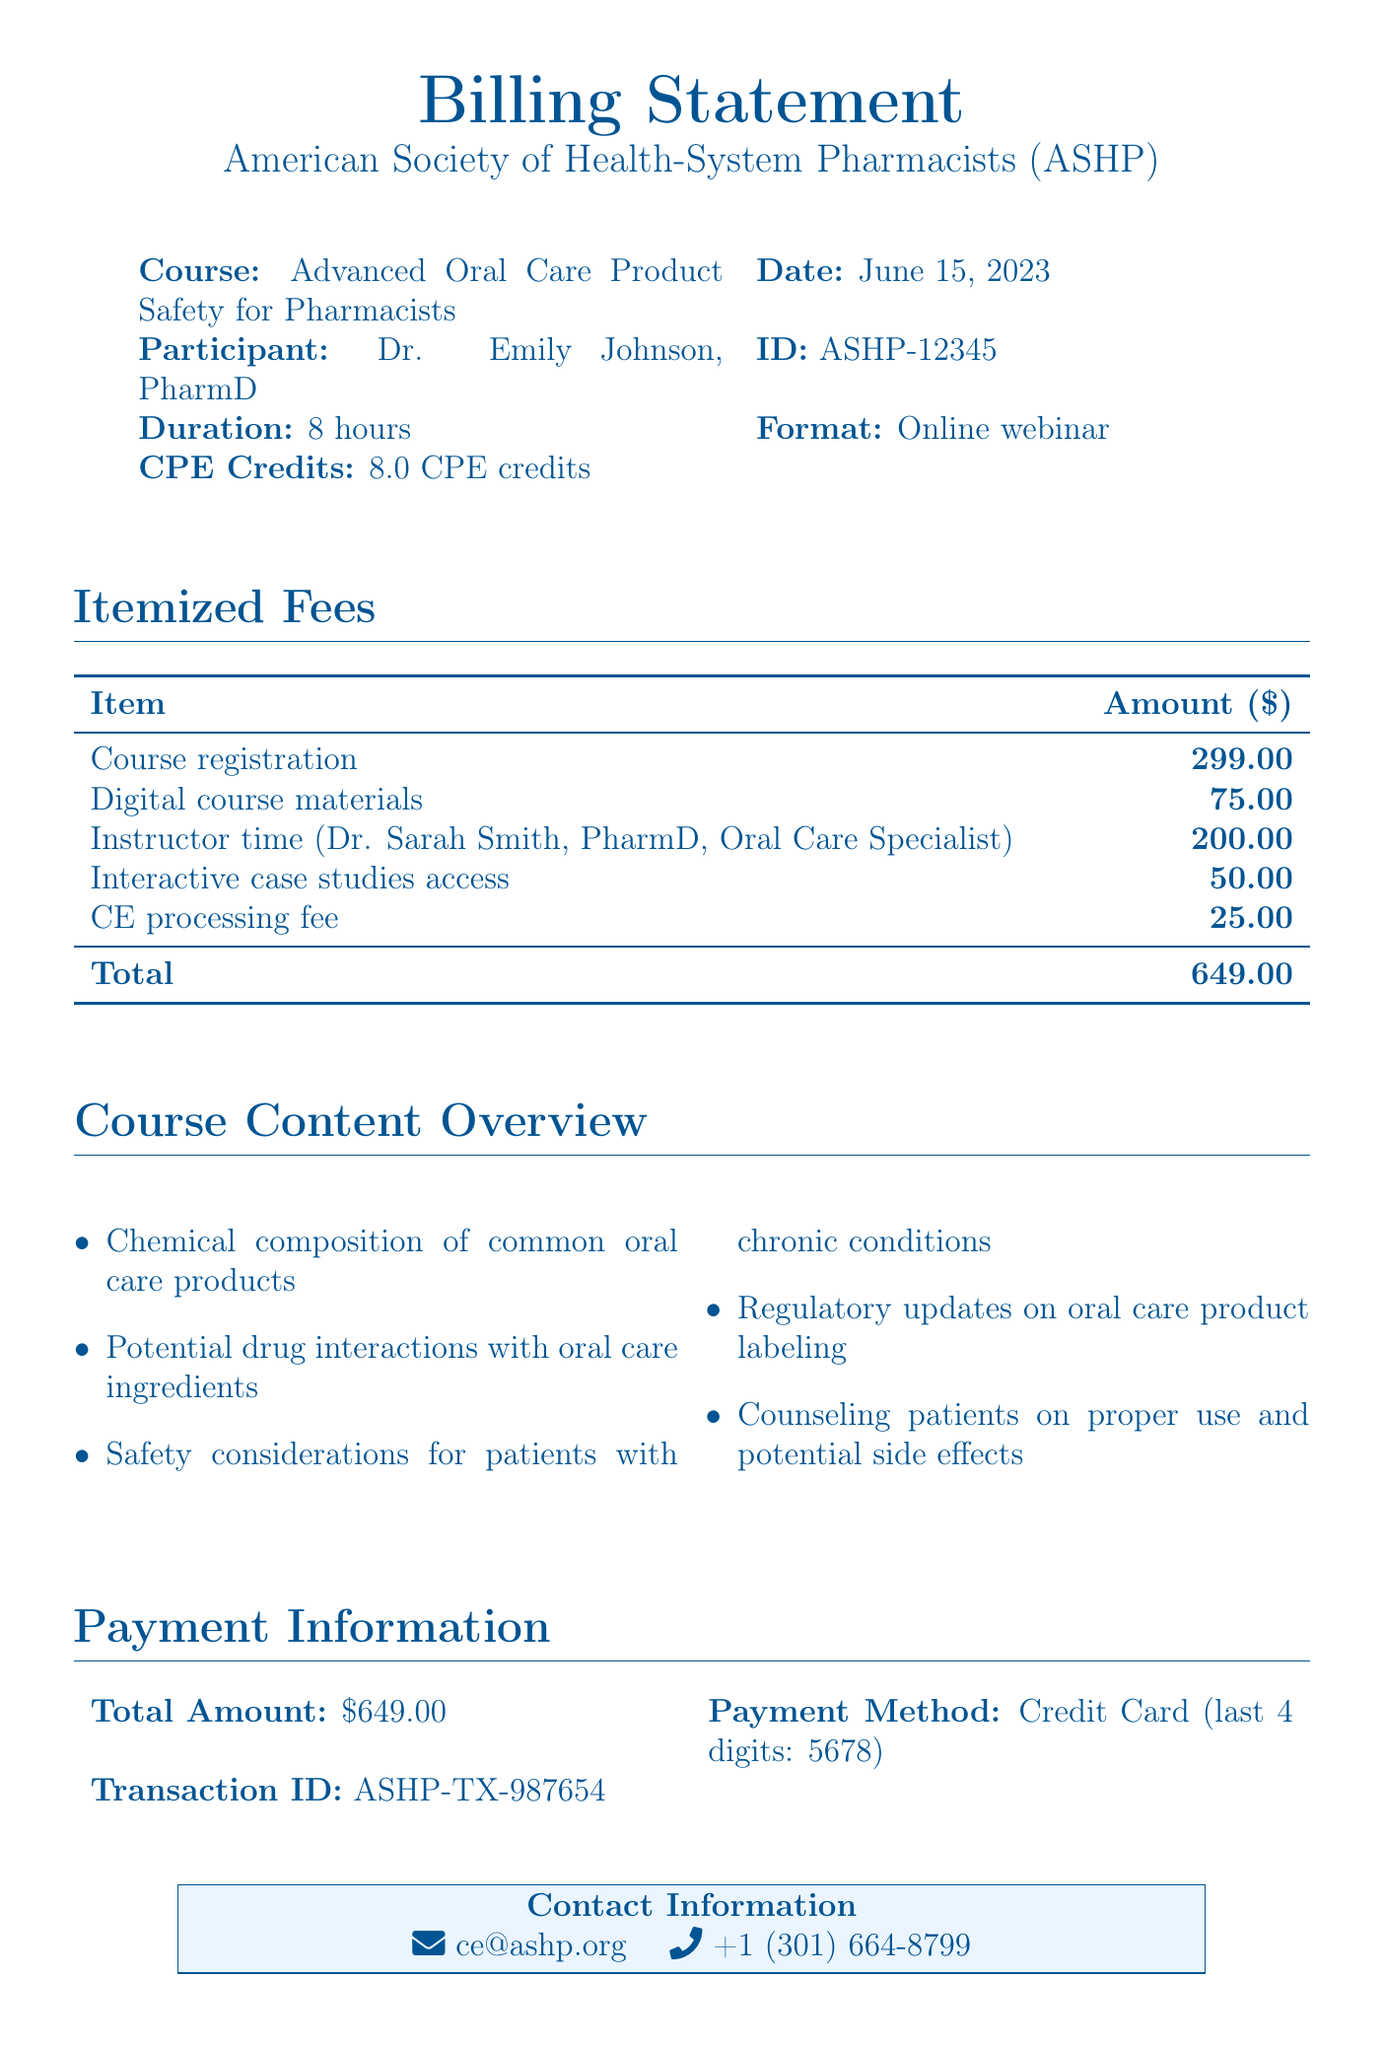What is the total amount due? The total amount due is listed at the bottom of the fee table as the overall sum of the itemized fees.
Answer: $649.00 Who is the instructor for the course? The document specifies the instructor's name and credentials, identifying them as an Oral Care Specialist.
Answer: Dr. Sarah Smith, PharmD What does CPE stand for? CPE is mentioned in the context of the course credits earned for continuing education in healthcare professions.
Answer: Continuing Pharmacy Education What is the duration of the course? The course duration is explicitly stated in the document, describing how long the online webinar lasts.
Answer: 8 hours What type of payment method was used? The payment method is indicated in the payment information section, specifying the type of card.
Answer: Credit Card What type of course is this? The document categorizes the educational offering, describing its focus area within pharmacy education.
Answer: Advanced Oral Care Product Safety for Pharmacists How much is charged for interactive case studies access? The specific fee for accessing interactive case studies is detailed in the itemized fees section.
Answer: $50.00 What date was the course held? The document states the exact date when the course took place, which is important for record-keeping.
Answer: June 15, 2023 